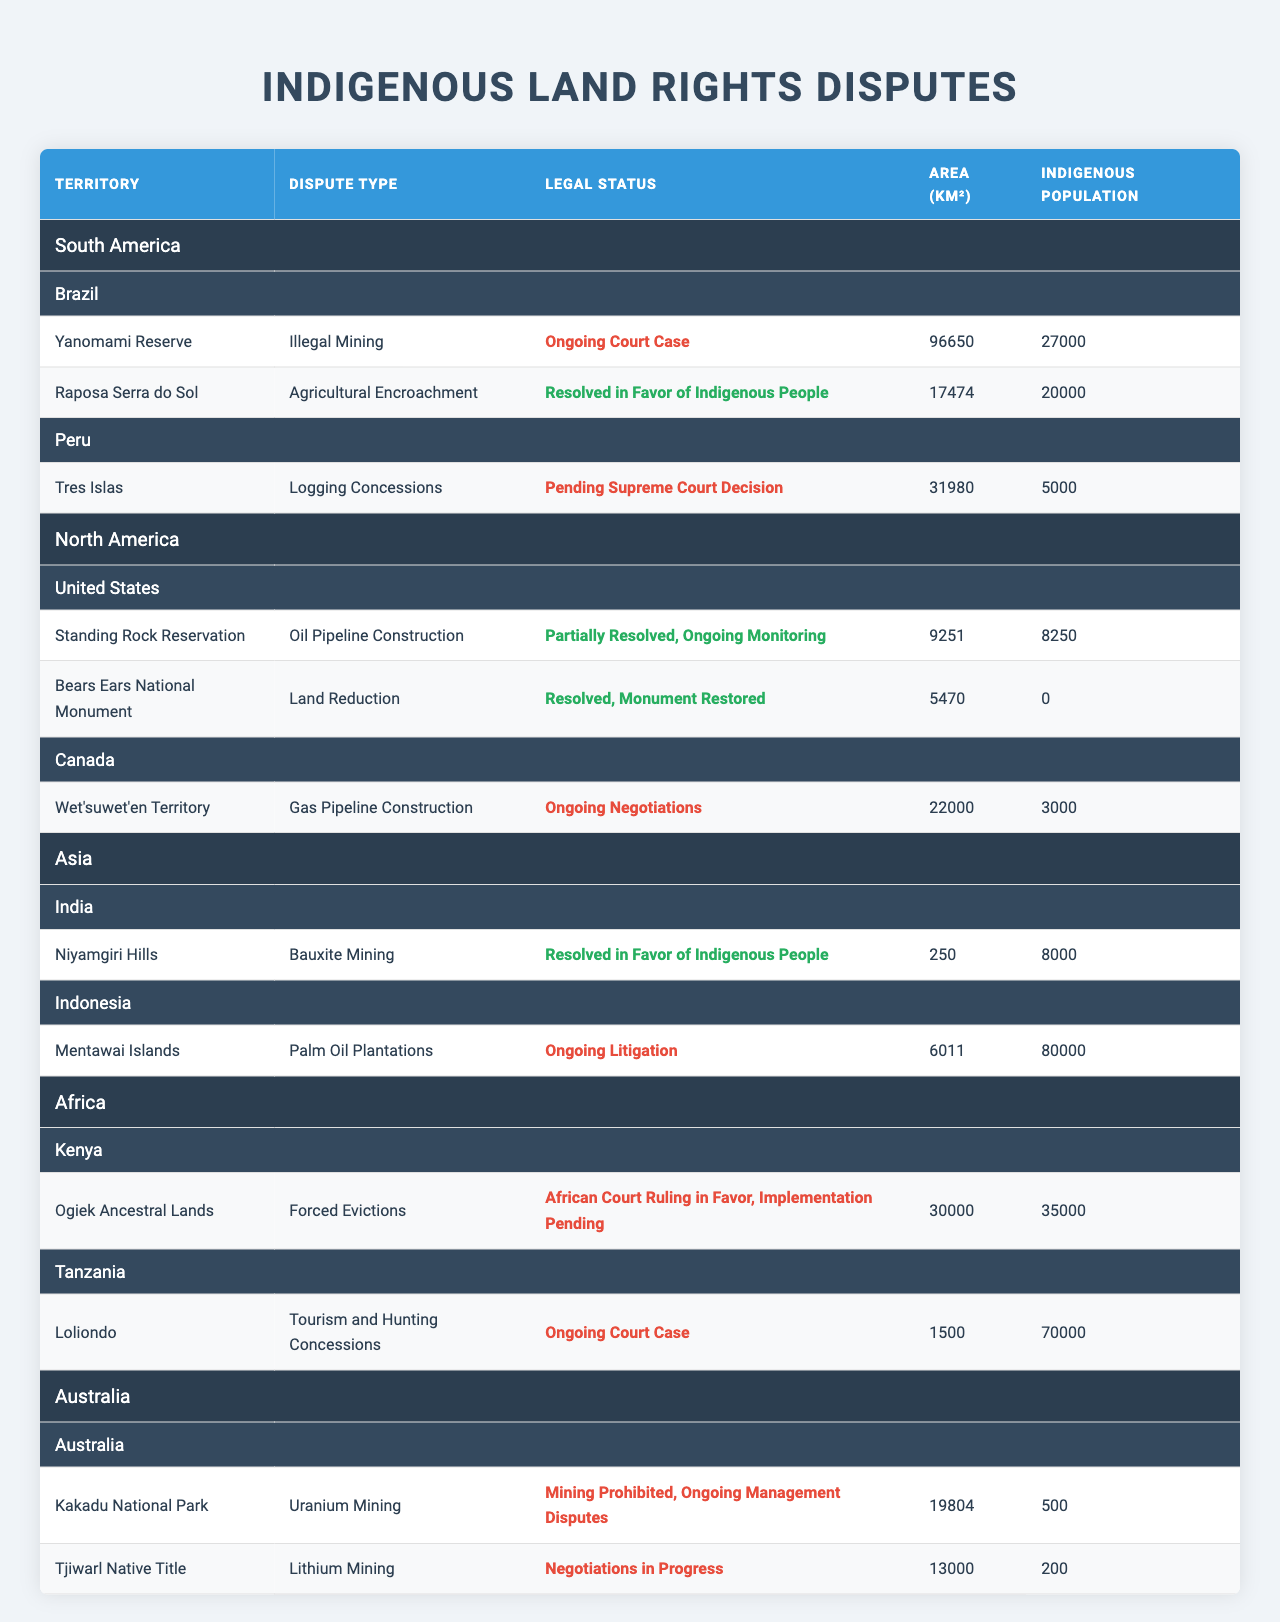What is the area of the Yanomami Reserve? The table lists the Yanomami Reserve under Brazil. Its area is specified as 96,650 km².
Answer: 96,650 km² Which country has the highest indigenous population involved in land rights disputes? In the table, the Mentawai Islands in Indonesia shows an indigenous population of 80,000, which is higher than any other territory listed.
Answer: Indonesia Is there any dispute in Canada that is resolved? The table indicates that the Bears Ears National Monument in the United States is resolved and mentions Canada having ongoing negotiations, implying no resolved disputes in Canada.
Answer: No How many territories are involved in land disputes in Brazil? The table lists two territories under Brazil: Yanomami Reserve and Raposa Serra do Sol, confirming a total of two territories involved.
Answer: 2 What is the total area of indigenous territories involved in disputes within North America? The total area is calculated by adding the areas of Standing Rock Reservation (9,251 km²) and Bears Ears National Monument (5,470 km²), totaling 14,721 km².
Answer: 14,721 km² Which dispute in Africa is still ongoing and what is it about? The table shows that the dispute in Tanzania's Loliondo territory is an ongoing court case concerning tourism and hunting concessions.
Answer: Ongoing court case about tourism and hunting concessions What percentage of the indigenous population in Brazil is represented in Raposa Serra do Sol? The indigenous population in Raposa Serra do Sol is 20,000. Considering Brazil has a total indigenous population of 27,000 in the Yanomami Reserve, the percentage is calculated as (20,000 / 27,000) * 100 ≈ 74.07%.
Answer: Approximately 74.07% How many countries have resolved land rights disputes in total? The table lists resolutions in Brazil (for Raposa Serra do Sol), India (Niyamgiri Hills), and the United States (Bears Ears), totaling three countries with resolved disputes.
Answer: 3 What is the difference in area between the largest and smallest territories listed? The largest territory is the Yanomami Reserve at 96,650 km², and the smallest is the Niyamgiri Hills at 250 km². The difference is calculated as 96,650 - 250 = 96,400 km².
Answer: 96,400 km² In which continent does the Mentawai Islands dispute occur? The table categorizes the Mentawai Islands as part of Indonesia, and Indonesia is located in Asia.
Answer: Asia 